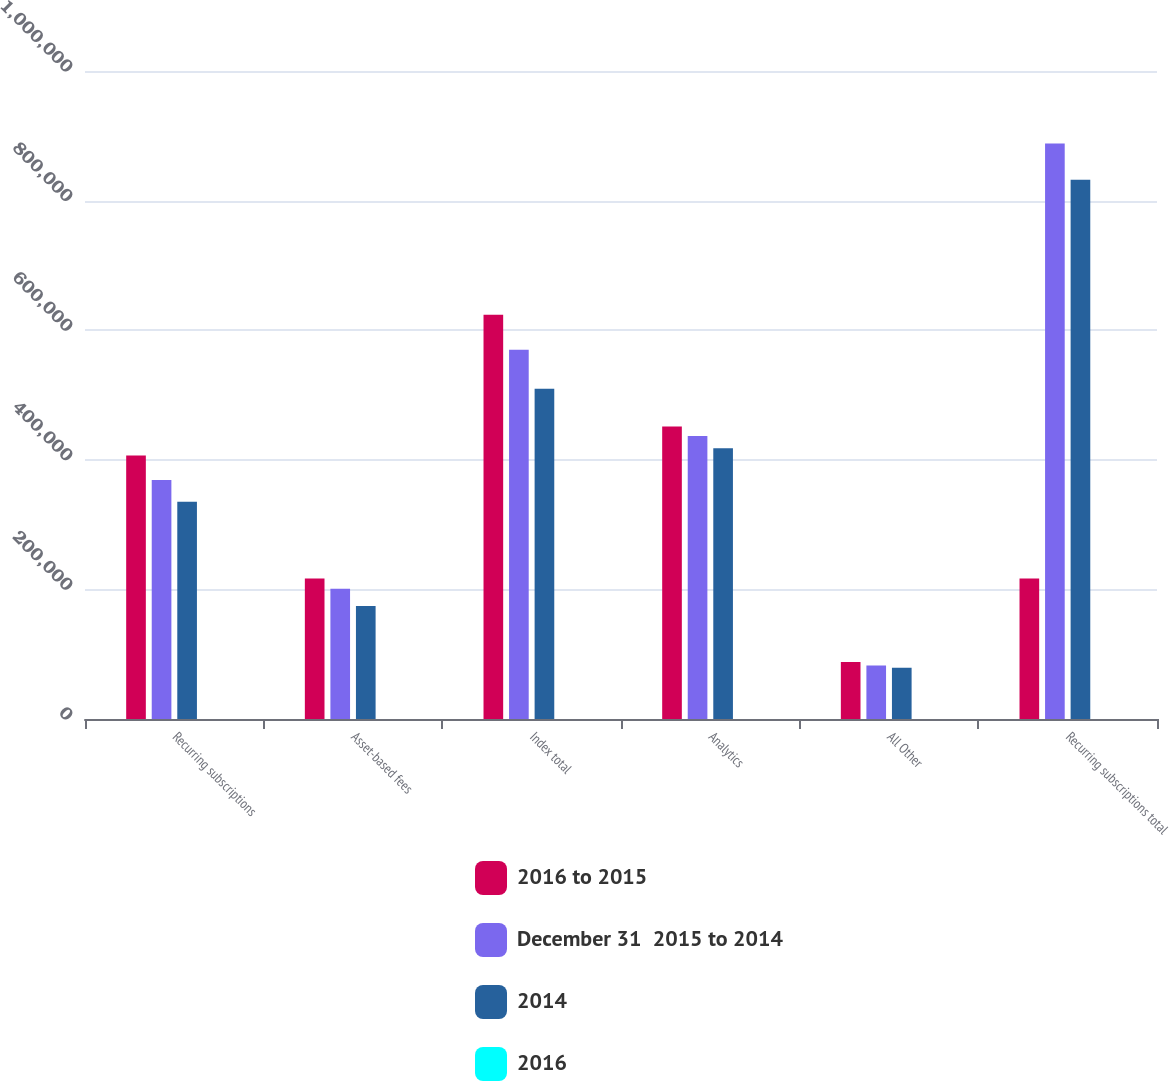Convert chart. <chart><loc_0><loc_0><loc_500><loc_500><stacked_bar_chart><ecel><fcel>Recurring subscriptions<fcel>Asset-based fees<fcel>Index total<fcel>Analytics<fcel>All Other<fcel>Recurring subscriptions total<nl><fcel>2016 to 2015<fcel>406729<fcel>216982<fcel>623711<fcel>451533<fcel>88074<fcel>216982<nl><fcel>December 31  2015 to 2014<fcel>368855<fcel>201047<fcel>569902<fcel>436671<fcel>82677<fcel>888203<nl><fcel>2014<fcel>335277<fcel>174558<fcel>509835<fcel>417677<fcel>79213<fcel>832167<nl><fcel>2016<fcel>10.3<fcel>7.9<fcel>9.4<fcel>3.4<fcel>6.5<fcel>6.5<nl></chart> 